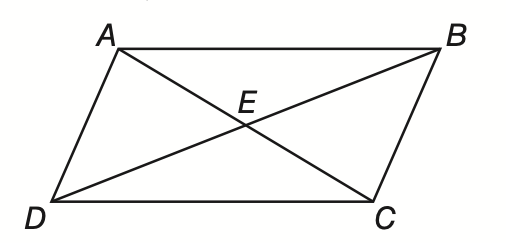Answer the mathemtical geometry problem and directly provide the correct option letter.
Question: In parallelogram A B C D, B D and A C intersect at E. If A E = 9, B E = 3 x - 7, and D E = x + 5, find x.
Choices: A: 4 B: 5 C: 6 D: 7 C 